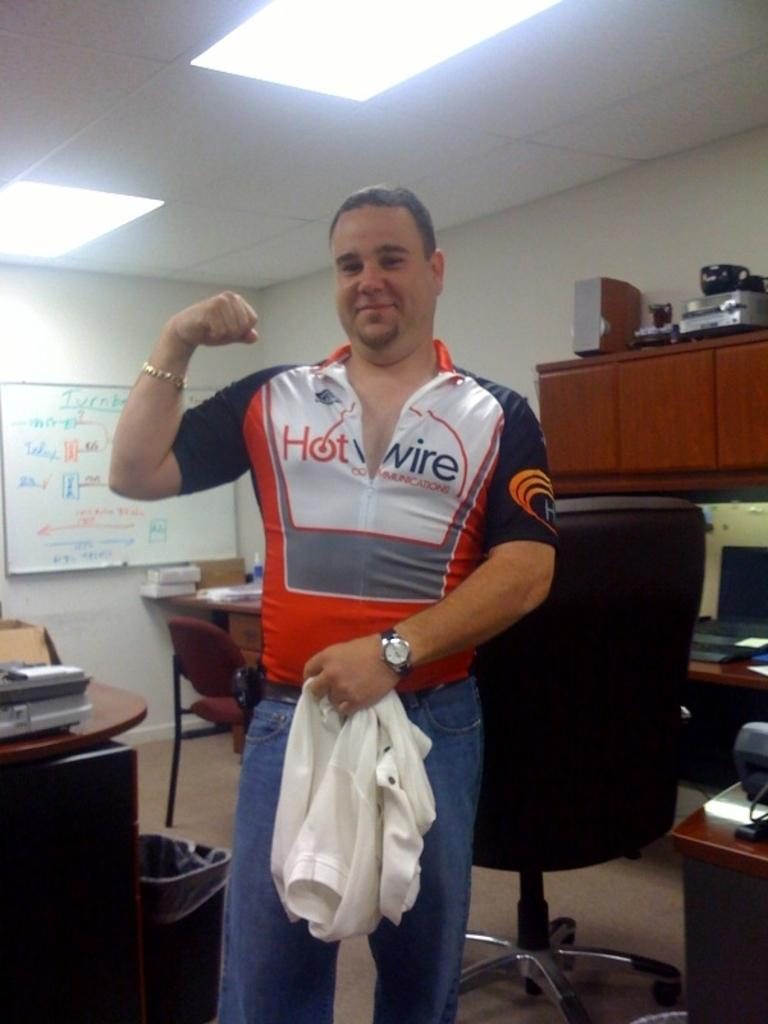<image>
Share a concise interpretation of the image provided. A man in his 30's doing an arm pump and holding a gym towel in the other hand while wearing a tight shirt which reads Hotwire. 